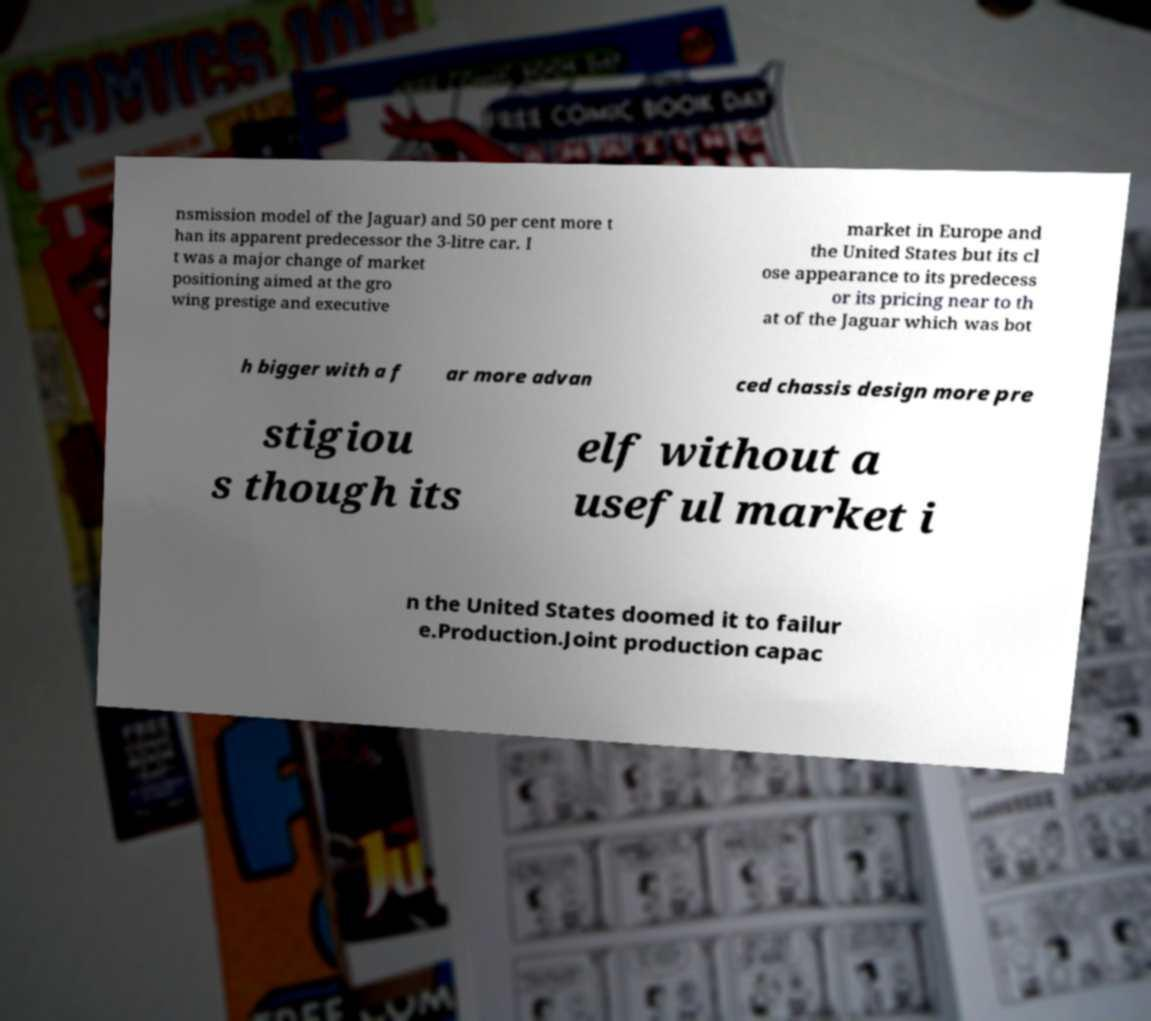Please read and relay the text visible in this image. What does it say? nsmission model of the Jaguar) and 50 per cent more t han its apparent predecessor the 3-litre car. I t was a major change of market positioning aimed at the gro wing prestige and executive market in Europe and the United States but its cl ose appearance to its predecess or its pricing near to th at of the Jaguar which was bot h bigger with a f ar more advan ced chassis design more pre stigiou s though its elf without a useful market i n the United States doomed it to failur e.Production.Joint production capac 